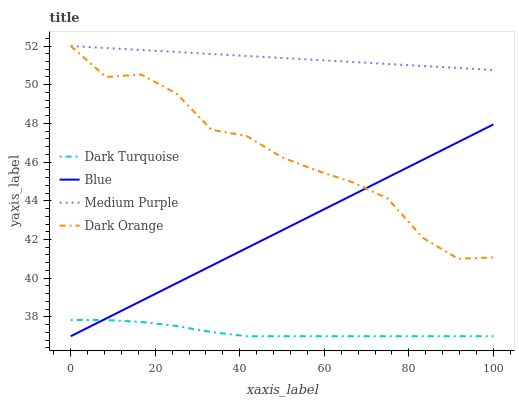Does Dark Turquoise have the minimum area under the curve?
Answer yes or no. Yes. Does Medium Purple have the maximum area under the curve?
Answer yes or no. Yes. Does Medium Purple have the minimum area under the curve?
Answer yes or no. No. Does Dark Turquoise have the maximum area under the curve?
Answer yes or no. No. Is Blue the smoothest?
Answer yes or no. Yes. Is Dark Orange the roughest?
Answer yes or no. Yes. Is Dark Turquoise the smoothest?
Answer yes or no. No. Is Dark Turquoise the roughest?
Answer yes or no. No. Does Blue have the lowest value?
Answer yes or no. Yes. Does Medium Purple have the lowest value?
Answer yes or no. No. Does Dark Orange have the highest value?
Answer yes or no. Yes. Does Dark Turquoise have the highest value?
Answer yes or no. No. Is Blue less than Medium Purple?
Answer yes or no. Yes. Is Dark Orange greater than Dark Turquoise?
Answer yes or no. Yes. Does Dark Orange intersect Blue?
Answer yes or no. Yes. Is Dark Orange less than Blue?
Answer yes or no. No. Is Dark Orange greater than Blue?
Answer yes or no. No. Does Blue intersect Medium Purple?
Answer yes or no. No. 